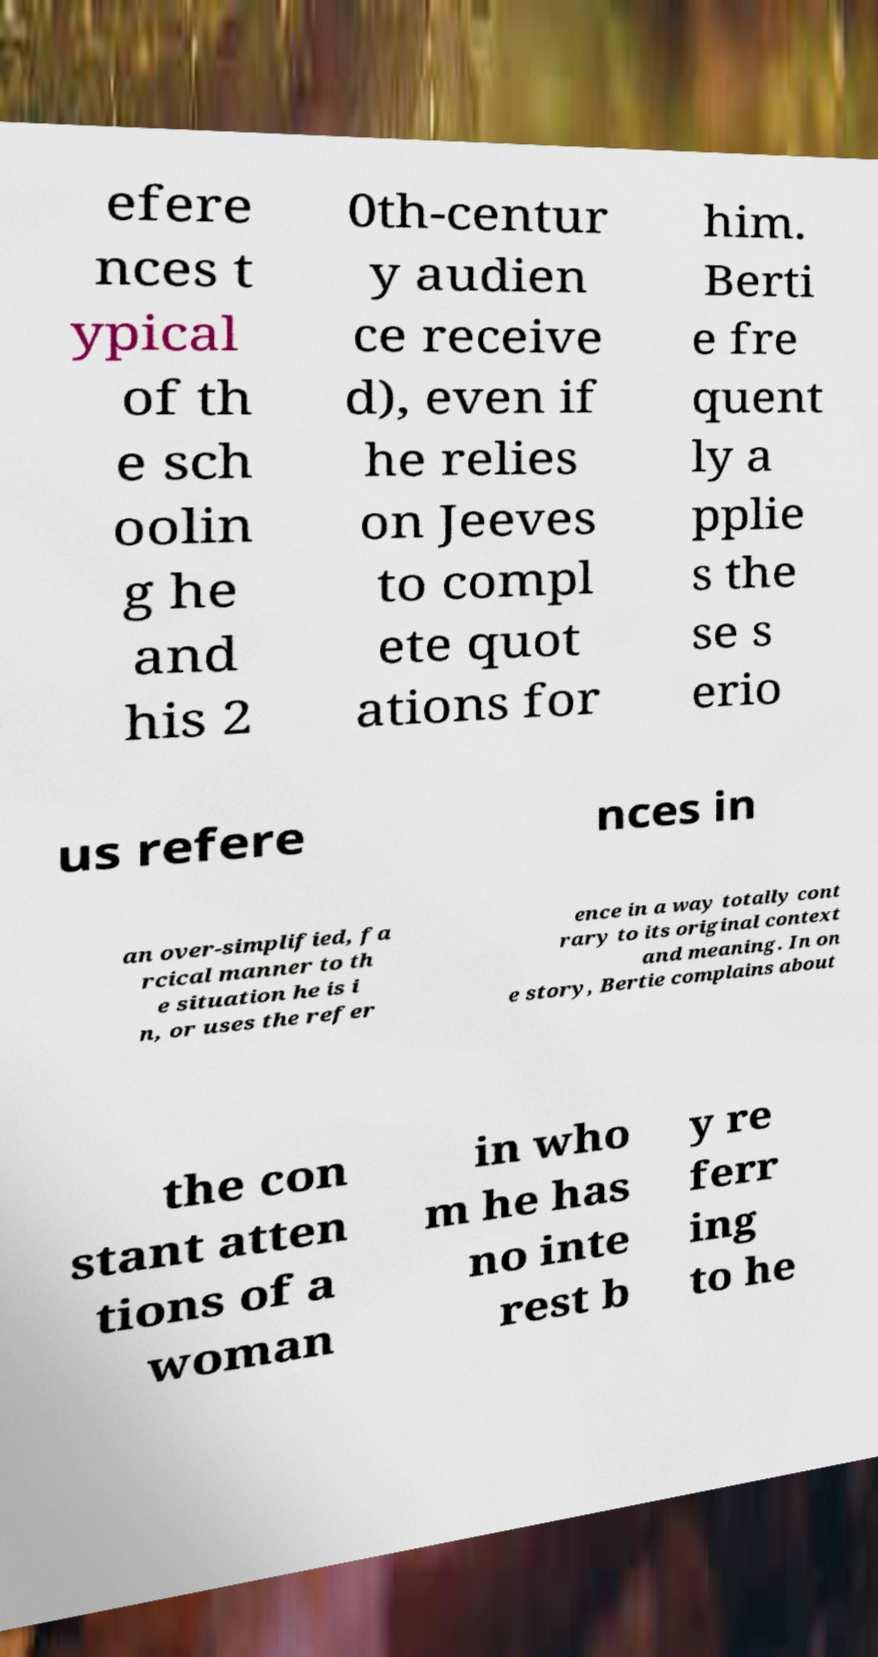Could you extract and type out the text from this image? efere nces t ypical of th e sch oolin g he and his 2 0th-centur y audien ce receive d), even if he relies on Jeeves to compl ete quot ations for him. Berti e fre quent ly a pplie s the se s erio us refere nces in an over-simplified, fa rcical manner to th e situation he is i n, or uses the refer ence in a way totally cont rary to its original context and meaning. In on e story, Bertie complains about the con stant atten tions of a woman in who m he has no inte rest b y re ferr ing to he 